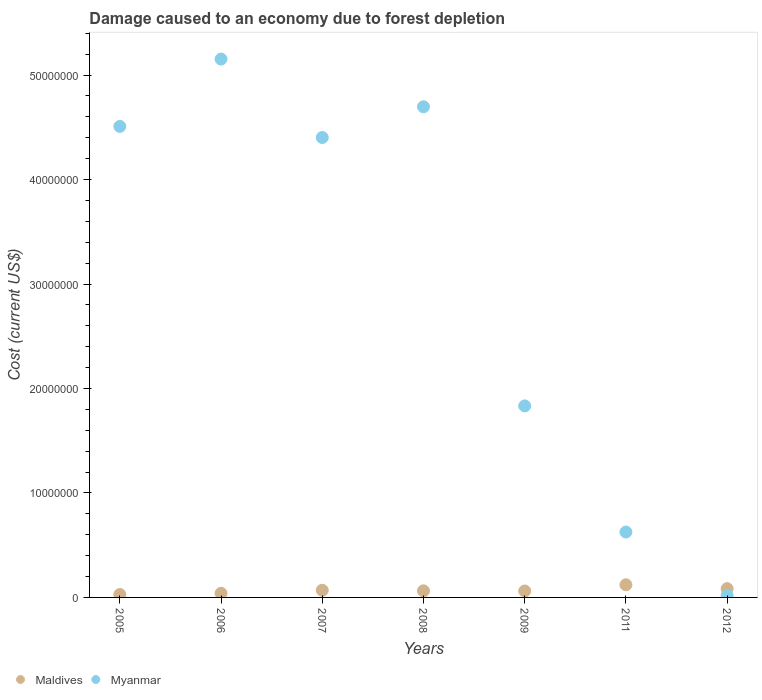How many different coloured dotlines are there?
Give a very brief answer. 2. Is the number of dotlines equal to the number of legend labels?
Provide a short and direct response. Yes. What is the cost of damage caused due to forest depletion in Myanmar in 2008?
Offer a very short reply. 4.70e+07. Across all years, what is the maximum cost of damage caused due to forest depletion in Maldives?
Offer a terse response. 1.21e+06. Across all years, what is the minimum cost of damage caused due to forest depletion in Myanmar?
Keep it short and to the point. 1.95e+05. In which year was the cost of damage caused due to forest depletion in Myanmar maximum?
Offer a terse response. 2006. In which year was the cost of damage caused due to forest depletion in Myanmar minimum?
Provide a succinct answer. 2012. What is the total cost of damage caused due to forest depletion in Myanmar in the graph?
Give a very brief answer. 2.12e+08. What is the difference between the cost of damage caused due to forest depletion in Myanmar in 2005 and that in 2009?
Your answer should be compact. 2.68e+07. What is the difference between the cost of damage caused due to forest depletion in Maldives in 2011 and the cost of damage caused due to forest depletion in Myanmar in 2008?
Offer a very short reply. -4.58e+07. What is the average cost of damage caused due to forest depletion in Myanmar per year?
Provide a succinct answer. 3.03e+07. In the year 2012, what is the difference between the cost of damage caused due to forest depletion in Myanmar and cost of damage caused due to forest depletion in Maldives?
Ensure brevity in your answer.  -6.45e+05. What is the ratio of the cost of damage caused due to forest depletion in Maldives in 2009 to that in 2012?
Provide a short and direct response. 0.73. What is the difference between the highest and the second highest cost of damage caused due to forest depletion in Maldives?
Provide a short and direct response. 3.71e+05. What is the difference between the highest and the lowest cost of damage caused due to forest depletion in Myanmar?
Give a very brief answer. 5.13e+07. In how many years, is the cost of damage caused due to forest depletion in Maldives greater than the average cost of damage caused due to forest depletion in Maldives taken over all years?
Your response must be concise. 3. Is the cost of damage caused due to forest depletion in Maldives strictly less than the cost of damage caused due to forest depletion in Myanmar over the years?
Make the answer very short. No. How many years are there in the graph?
Keep it short and to the point. 7. Where does the legend appear in the graph?
Keep it short and to the point. Bottom left. What is the title of the graph?
Ensure brevity in your answer.  Damage caused to an economy due to forest depletion. What is the label or title of the Y-axis?
Your answer should be very brief. Cost (current US$). What is the Cost (current US$) in Maldives in 2005?
Ensure brevity in your answer.  2.80e+05. What is the Cost (current US$) in Myanmar in 2005?
Keep it short and to the point. 4.51e+07. What is the Cost (current US$) of Maldives in 2006?
Your response must be concise. 3.94e+05. What is the Cost (current US$) of Myanmar in 2006?
Provide a short and direct response. 5.15e+07. What is the Cost (current US$) of Maldives in 2007?
Offer a terse response. 6.85e+05. What is the Cost (current US$) of Myanmar in 2007?
Provide a short and direct response. 4.40e+07. What is the Cost (current US$) of Maldives in 2008?
Your answer should be very brief. 6.31e+05. What is the Cost (current US$) of Myanmar in 2008?
Offer a terse response. 4.70e+07. What is the Cost (current US$) of Maldives in 2009?
Your answer should be compact. 6.14e+05. What is the Cost (current US$) in Myanmar in 2009?
Ensure brevity in your answer.  1.83e+07. What is the Cost (current US$) of Maldives in 2011?
Your response must be concise. 1.21e+06. What is the Cost (current US$) in Myanmar in 2011?
Make the answer very short. 6.26e+06. What is the Cost (current US$) of Maldives in 2012?
Provide a short and direct response. 8.40e+05. What is the Cost (current US$) in Myanmar in 2012?
Make the answer very short. 1.95e+05. Across all years, what is the maximum Cost (current US$) of Maldives?
Provide a short and direct response. 1.21e+06. Across all years, what is the maximum Cost (current US$) in Myanmar?
Ensure brevity in your answer.  5.15e+07. Across all years, what is the minimum Cost (current US$) in Maldives?
Your response must be concise. 2.80e+05. Across all years, what is the minimum Cost (current US$) in Myanmar?
Ensure brevity in your answer.  1.95e+05. What is the total Cost (current US$) in Maldives in the graph?
Keep it short and to the point. 4.66e+06. What is the total Cost (current US$) of Myanmar in the graph?
Give a very brief answer. 2.12e+08. What is the difference between the Cost (current US$) of Maldives in 2005 and that in 2006?
Provide a succinct answer. -1.14e+05. What is the difference between the Cost (current US$) in Myanmar in 2005 and that in 2006?
Your answer should be very brief. -6.45e+06. What is the difference between the Cost (current US$) of Maldives in 2005 and that in 2007?
Offer a very short reply. -4.05e+05. What is the difference between the Cost (current US$) of Myanmar in 2005 and that in 2007?
Keep it short and to the point. 1.06e+06. What is the difference between the Cost (current US$) of Maldives in 2005 and that in 2008?
Provide a short and direct response. -3.51e+05. What is the difference between the Cost (current US$) in Myanmar in 2005 and that in 2008?
Provide a short and direct response. -1.88e+06. What is the difference between the Cost (current US$) of Maldives in 2005 and that in 2009?
Make the answer very short. -3.34e+05. What is the difference between the Cost (current US$) of Myanmar in 2005 and that in 2009?
Offer a very short reply. 2.68e+07. What is the difference between the Cost (current US$) in Maldives in 2005 and that in 2011?
Provide a succinct answer. -9.32e+05. What is the difference between the Cost (current US$) in Myanmar in 2005 and that in 2011?
Ensure brevity in your answer.  3.88e+07. What is the difference between the Cost (current US$) of Maldives in 2005 and that in 2012?
Make the answer very short. -5.60e+05. What is the difference between the Cost (current US$) of Myanmar in 2005 and that in 2012?
Ensure brevity in your answer.  4.49e+07. What is the difference between the Cost (current US$) in Maldives in 2006 and that in 2007?
Keep it short and to the point. -2.90e+05. What is the difference between the Cost (current US$) in Myanmar in 2006 and that in 2007?
Give a very brief answer. 7.51e+06. What is the difference between the Cost (current US$) in Maldives in 2006 and that in 2008?
Offer a terse response. -2.36e+05. What is the difference between the Cost (current US$) of Myanmar in 2006 and that in 2008?
Offer a very short reply. 4.57e+06. What is the difference between the Cost (current US$) of Maldives in 2006 and that in 2009?
Keep it short and to the point. -2.20e+05. What is the difference between the Cost (current US$) in Myanmar in 2006 and that in 2009?
Your answer should be compact. 3.32e+07. What is the difference between the Cost (current US$) in Maldives in 2006 and that in 2011?
Your answer should be compact. -8.17e+05. What is the difference between the Cost (current US$) in Myanmar in 2006 and that in 2011?
Ensure brevity in your answer.  4.53e+07. What is the difference between the Cost (current US$) in Maldives in 2006 and that in 2012?
Offer a very short reply. -4.46e+05. What is the difference between the Cost (current US$) in Myanmar in 2006 and that in 2012?
Offer a terse response. 5.13e+07. What is the difference between the Cost (current US$) of Maldives in 2007 and that in 2008?
Your answer should be very brief. 5.40e+04. What is the difference between the Cost (current US$) in Myanmar in 2007 and that in 2008?
Offer a terse response. -2.94e+06. What is the difference between the Cost (current US$) of Maldives in 2007 and that in 2009?
Keep it short and to the point. 7.04e+04. What is the difference between the Cost (current US$) of Myanmar in 2007 and that in 2009?
Your answer should be very brief. 2.57e+07. What is the difference between the Cost (current US$) of Maldives in 2007 and that in 2011?
Give a very brief answer. -5.27e+05. What is the difference between the Cost (current US$) in Myanmar in 2007 and that in 2011?
Your response must be concise. 3.78e+07. What is the difference between the Cost (current US$) of Maldives in 2007 and that in 2012?
Provide a succinct answer. -1.55e+05. What is the difference between the Cost (current US$) of Myanmar in 2007 and that in 2012?
Ensure brevity in your answer.  4.38e+07. What is the difference between the Cost (current US$) in Maldives in 2008 and that in 2009?
Offer a very short reply. 1.65e+04. What is the difference between the Cost (current US$) in Myanmar in 2008 and that in 2009?
Ensure brevity in your answer.  2.86e+07. What is the difference between the Cost (current US$) in Maldives in 2008 and that in 2011?
Keep it short and to the point. -5.81e+05. What is the difference between the Cost (current US$) in Myanmar in 2008 and that in 2011?
Ensure brevity in your answer.  4.07e+07. What is the difference between the Cost (current US$) of Maldives in 2008 and that in 2012?
Your answer should be very brief. -2.09e+05. What is the difference between the Cost (current US$) of Myanmar in 2008 and that in 2012?
Offer a terse response. 4.68e+07. What is the difference between the Cost (current US$) in Maldives in 2009 and that in 2011?
Offer a terse response. -5.97e+05. What is the difference between the Cost (current US$) of Myanmar in 2009 and that in 2011?
Make the answer very short. 1.21e+07. What is the difference between the Cost (current US$) of Maldives in 2009 and that in 2012?
Provide a short and direct response. -2.26e+05. What is the difference between the Cost (current US$) of Myanmar in 2009 and that in 2012?
Offer a very short reply. 1.81e+07. What is the difference between the Cost (current US$) in Maldives in 2011 and that in 2012?
Your answer should be compact. 3.71e+05. What is the difference between the Cost (current US$) of Myanmar in 2011 and that in 2012?
Your answer should be very brief. 6.06e+06. What is the difference between the Cost (current US$) in Maldives in 2005 and the Cost (current US$) in Myanmar in 2006?
Your response must be concise. -5.13e+07. What is the difference between the Cost (current US$) of Maldives in 2005 and the Cost (current US$) of Myanmar in 2007?
Ensure brevity in your answer.  -4.37e+07. What is the difference between the Cost (current US$) of Maldives in 2005 and the Cost (current US$) of Myanmar in 2008?
Ensure brevity in your answer.  -4.67e+07. What is the difference between the Cost (current US$) in Maldives in 2005 and the Cost (current US$) in Myanmar in 2009?
Keep it short and to the point. -1.81e+07. What is the difference between the Cost (current US$) in Maldives in 2005 and the Cost (current US$) in Myanmar in 2011?
Your response must be concise. -5.98e+06. What is the difference between the Cost (current US$) of Maldives in 2005 and the Cost (current US$) of Myanmar in 2012?
Offer a very short reply. 8.50e+04. What is the difference between the Cost (current US$) of Maldives in 2006 and the Cost (current US$) of Myanmar in 2007?
Your answer should be compact. -4.36e+07. What is the difference between the Cost (current US$) in Maldives in 2006 and the Cost (current US$) in Myanmar in 2008?
Your answer should be very brief. -4.66e+07. What is the difference between the Cost (current US$) of Maldives in 2006 and the Cost (current US$) of Myanmar in 2009?
Make the answer very short. -1.79e+07. What is the difference between the Cost (current US$) of Maldives in 2006 and the Cost (current US$) of Myanmar in 2011?
Your answer should be very brief. -5.86e+06. What is the difference between the Cost (current US$) of Maldives in 2006 and the Cost (current US$) of Myanmar in 2012?
Your response must be concise. 1.99e+05. What is the difference between the Cost (current US$) of Maldives in 2007 and the Cost (current US$) of Myanmar in 2008?
Keep it short and to the point. -4.63e+07. What is the difference between the Cost (current US$) in Maldives in 2007 and the Cost (current US$) in Myanmar in 2009?
Your answer should be very brief. -1.76e+07. What is the difference between the Cost (current US$) in Maldives in 2007 and the Cost (current US$) in Myanmar in 2011?
Offer a terse response. -5.57e+06. What is the difference between the Cost (current US$) in Maldives in 2007 and the Cost (current US$) in Myanmar in 2012?
Offer a very short reply. 4.90e+05. What is the difference between the Cost (current US$) of Maldives in 2008 and the Cost (current US$) of Myanmar in 2009?
Make the answer very short. -1.77e+07. What is the difference between the Cost (current US$) of Maldives in 2008 and the Cost (current US$) of Myanmar in 2011?
Ensure brevity in your answer.  -5.63e+06. What is the difference between the Cost (current US$) of Maldives in 2008 and the Cost (current US$) of Myanmar in 2012?
Offer a very short reply. 4.36e+05. What is the difference between the Cost (current US$) in Maldives in 2009 and the Cost (current US$) in Myanmar in 2011?
Keep it short and to the point. -5.64e+06. What is the difference between the Cost (current US$) of Maldives in 2009 and the Cost (current US$) of Myanmar in 2012?
Offer a terse response. 4.19e+05. What is the difference between the Cost (current US$) of Maldives in 2011 and the Cost (current US$) of Myanmar in 2012?
Ensure brevity in your answer.  1.02e+06. What is the average Cost (current US$) in Maldives per year?
Your response must be concise. 6.65e+05. What is the average Cost (current US$) of Myanmar per year?
Make the answer very short. 3.03e+07. In the year 2005, what is the difference between the Cost (current US$) in Maldives and Cost (current US$) in Myanmar?
Offer a very short reply. -4.48e+07. In the year 2006, what is the difference between the Cost (current US$) of Maldives and Cost (current US$) of Myanmar?
Give a very brief answer. -5.11e+07. In the year 2007, what is the difference between the Cost (current US$) of Maldives and Cost (current US$) of Myanmar?
Give a very brief answer. -4.33e+07. In the year 2008, what is the difference between the Cost (current US$) of Maldives and Cost (current US$) of Myanmar?
Offer a very short reply. -4.63e+07. In the year 2009, what is the difference between the Cost (current US$) of Maldives and Cost (current US$) of Myanmar?
Offer a very short reply. -1.77e+07. In the year 2011, what is the difference between the Cost (current US$) of Maldives and Cost (current US$) of Myanmar?
Keep it short and to the point. -5.05e+06. In the year 2012, what is the difference between the Cost (current US$) of Maldives and Cost (current US$) of Myanmar?
Your answer should be very brief. 6.45e+05. What is the ratio of the Cost (current US$) of Maldives in 2005 to that in 2006?
Your answer should be compact. 0.71. What is the ratio of the Cost (current US$) of Myanmar in 2005 to that in 2006?
Offer a very short reply. 0.87. What is the ratio of the Cost (current US$) of Maldives in 2005 to that in 2007?
Keep it short and to the point. 0.41. What is the ratio of the Cost (current US$) in Myanmar in 2005 to that in 2007?
Keep it short and to the point. 1.02. What is the ratio of the Cost (current US$) of Maldives in 2005 to that in 2008?
Offer a terse response. 0.44. What is the ratio of the Cost (current US$) of Myanmar in 2005 to that in 2008?
Keep it short and to the point. 0.96. What is the ratio of the Cost (current US$) of Maldives in 2005 to that in 2009?
Keep it short and to the point. 0.46. What is the ratio of the Cost (current US$) in Myanmar in 2005 to that in 2009?
Your response must be concise. 2.46. What is the ratio of the Cost (current US$) of Maldives in 2005 to that in 2011?
Your answer should be very brief. 0.23. What is the ratio of the Cost (current US$) of Myanmar in 2005 to that in 2011?
Your answer should be compact. 7.2. What is the ratio of the Cost (current US$) of Maldives in 2005 to that in 2012?
Your answer should be very brief. 0.33. What is the ratio of the Cost (current US$) of Myanmar in 2005 to that in 2012?
Your response must be concise. 231.14. What is the ratio of the Cost (current US$) of Maldives in 2006 to that in 2007?
Your response must be concise. 0.58. What is the ratio of the Cost (current US$) in Myanmar in 2006 to that in 2007?
Keep it short and to the point. 1.17. What is the ratio of the Cost (current US$) of Maldives in 2006 to that in 2008?
Give a very brief answer. 0.63. What is the ratio of the Cost (current US$) of Myanmar in 2006 to that in 2008?
Your answer should be very brief. 1.1. What is the ratio of the Cost (current US$) in Maldives in 2006 to that in 2009?
Provide a short and direct response. 0.64. What is the ratio of the Cost (current US$) in Myanmar in 2006 to that in 2009?
Your answer should be compact. 2.81. What is the ratio of the Cost (current US$) in Maldives in 2006 to that in 2011?
Ensure brevity in your answer.  0.33. What is the ratio of the Cost (current US$) of Myanmar in 2006 to that in 2011?
Provide a short and direct response. 8.23. What is the ratio of the Cost (current US$) of Maldives in 2006 to that in 2012?
Provide a short and direct response. 0.47. What is the ratio of the Cost (current US$) in Myanmar in 2006 to that in 2012?
Ensure brevity in your answer.  264.19. What is the ratio of the Cost (current US$) in Maldives in 2007 to that in 2008?
Your response must be concise. 1.09. What is the ratio of the Cost (current US$) in Myanmar in 2007 to that in 2008?
Make the answer very short. 0.94. What is the ratio of the Cost (current US$) of Maldives in 2007 to that in 2009?
Give a very brief answer. 1.11. What is the ratio of the Cost (current US$) in Myanmar in 2007 to that in 2009?
Ensure brevity in your answer.  2.4. What is the ratio of the Cost (current US$) of Maldives in 2007 to that in 2011?
Offer a terse response. 0.57. What is the ratio of the Cost (current US$) in Myanmar in 2007 to that in 2011?
Give a very brief answer. 7.04. What is the ratio of the Cost (current US$) in Maldives in 2007 to that in 2012?
Ensure brevity in your answer.  0.82. What is the ratio of the Cost (current US$) of Myanmar in 2007 to that in 2012?
Your response must be concise. 225.69. What is the ratio of the Cost (current US$) in Maldives in 2008 to that in 2009?
Give a very brief answer. 1.03. What is the ratio of the Cost (current US$) of Myanmar in 2008 to that in 2009?
Provide a succinct answer. 2.56. What is the ratio of the Cost (current US$) in Maldives in 2008 to that in 2011?
Keep it short and to the point. 0.52. What is the ratio of the Cost (current US$) in Myanmar in 2008 to that in 2011?
Provide a succinct answer. 7.51. What is the ratio of the Cost (current US$) of Maldives in 2008 to that in 2012?
Provide a succinct answer. 0.75. What is the ratio of the Cost (current US$) of Myanmar in 2008 to that in 2012?
Keep it short and to the point. 240.77. What is the ratio of the Cost (current US$) of Maldives in 2009 to that in 2011?
Your answer should be very brief. 0.51. What is the ratio of the Cost (current US$) in Myanmar in 2009 to that in 2011?
Your answer should be very brief. 2.93. What is the ratio of the Cost (current US$) of Maldives in 2009 to that in 2012?
Make the answer very short. 0.73. What is the ratio of the Cost (current US$) of Myanmar in 2009 to that in 2012?
Give a very brief answer. 93.98. What is the ratio of the Cost (current US$) of Maldives in 2011 to that in 2012?
Offer a very short reply. 1.44. What is the ratio of the Cost (current US$) in Myanmar in 2011 to that in 2012?
Offer a terse response. 32.08. What is the difference between the highest and the second highest Cost (current US$) in Maldives?
Provide a succinct answer. 3.71e+05. What is the difference between the highest and the second highest Cost (current US$) in Myanmar?
Give a very brief answer. 4.57e+06. What is the difference between the highest and the lowest Cost (current US$) of Maldives?
Ensure brevity in your answer.  9.32e+05. What is the difference between the highest and the lowest Cost (current US$) in Myanmar?
Offer a very short reply. 5.13e+07. 